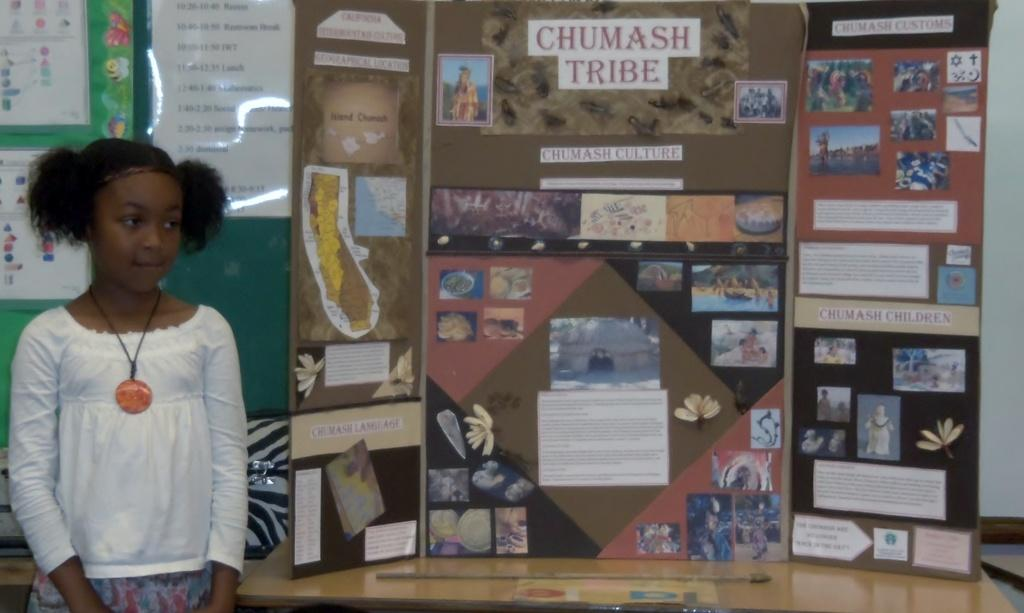What is the main subject of the image? There is a child standing in the image. What can be seen in the background of the image? There is a board in the background of the image. What is on the board? Photographs are present on the board, along with text. What type of toys can be seen on the linen in the image? There are no toys or linen present in the image. 